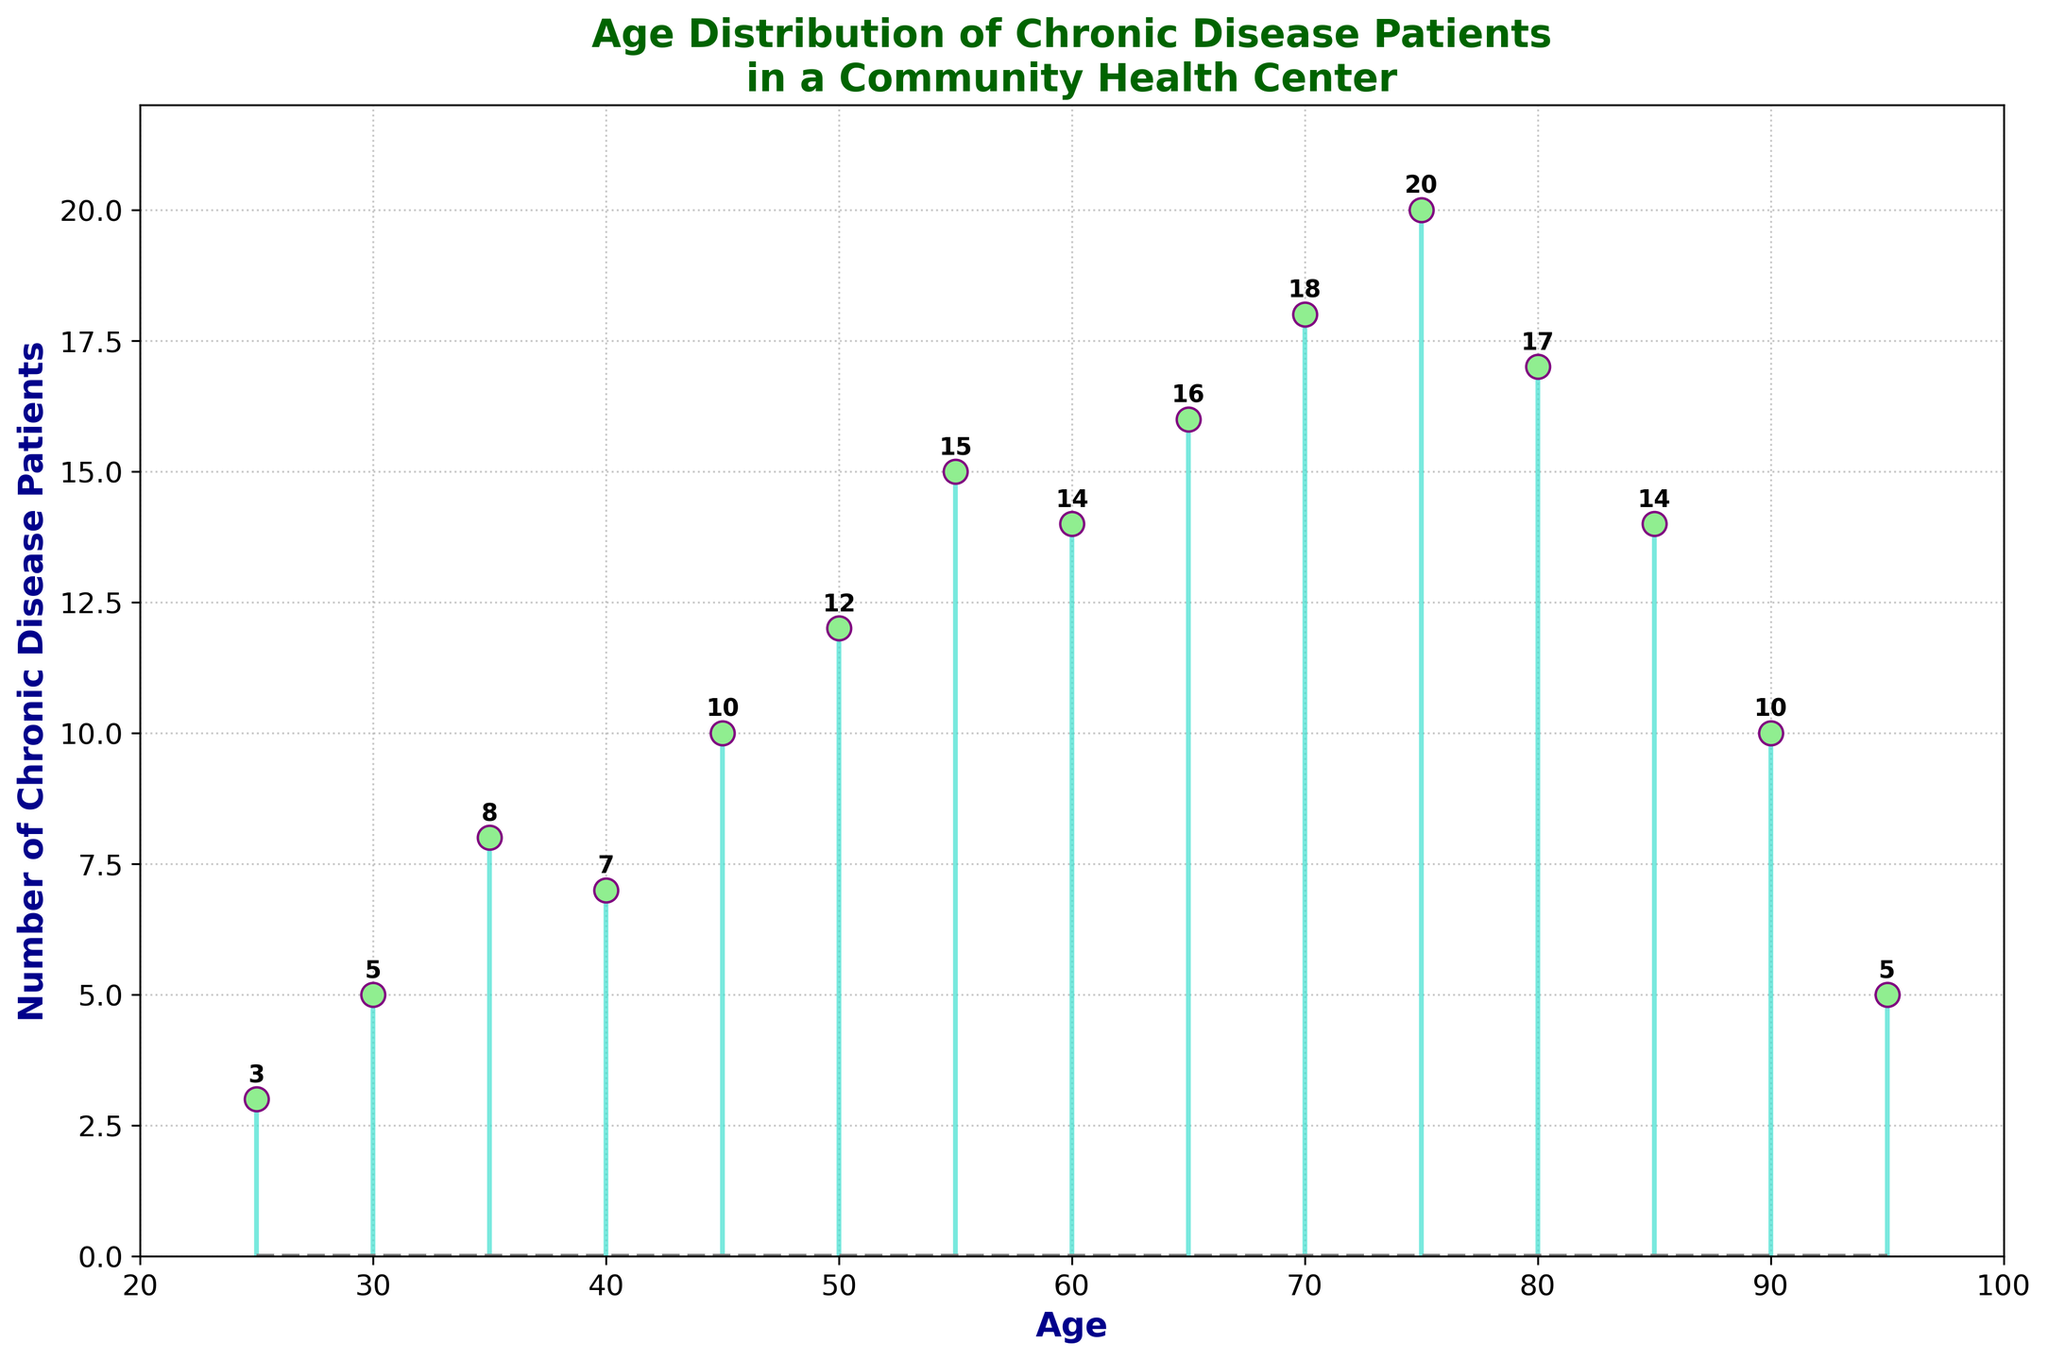What is the highest number of chronic disease patients, and at what age does this occur? To find this information, look for the highest point on the plot's vertical axis and check the corresponding age on the horizontal axis. The highest value on the vertical axis is 20, and this occurs at age 75.
Answer: 20, 75 At which ages are there exactly 14 chronic disease patients? Search for the points on the plot where the value on the vertical axis equals 14 and check the corresponding ages on the horizontal axis. There are two points where the value is 14, which corresponds to ages 60 and 85.
Answer: 60, 85 What are the minimum and maximum age values shown in the figure? The age range can be determined by looking at the first and last points on the horizontal axis in the plot. The minimum age shown is 25, and the maximum age shown is 95.
Answer: 25, 95 What is the total number of chronic disease patients in all age groups combined? To find this sum, add up the values of chronic disease patients for all ages: 3 + 5 + 8 + 7 + 10 + 12 + 15 + 14 + 16 + 18 + 20 + 17 + 14 + 10 + 5 = 174.
Answer: 174 Which age group has fewer chronic disease patients, age 85 or age 90? Compare the number of chronic disease patients at age 85 with those at age 90. At age 85, there are 14 patients, and at age 90, there are 10 patients. Thus, age 90 has fewer patients.
Answer: 90 How does the number of chronic disease patients change between the ages of 50 and 60? Check the number of chronic disease patients at age 50 and compare it to the number at age 60. At age 50, there are 12 patients, and at age 60, there are 14 patients. The number of patients increases by 2.
Answer: Increases by 2 What's the average number of chronic disease patients for all ages shown in the figure? First, find the total number of patients by summing up all numbers: 3 + 5 + 8 + 7 + 10 + 12 + 15 + 14 + 16 + 18 + 20 + 17 + 14 + 10 + 5 = 174. Then, divide this sum by the number of age points (15): 174 / 15 ≈ 11.6.
Answer: 11.6 Which age group has the most significant difference in patients compared to the one immediately before it? Calculate the differences in the number of patients for successive age groups: 5-3=2, 8-5=3, 7-8=-1, 10-7=3, 12-10=2, 15-12=3, 14-15=-1, 16-14=2, 18-16=2, 20-18=2, 17-20=-3, 14-17=-3, 10-14=-4, 5-10=-5. The most significant change is from age 90 to 95 (-5).
Answer: Ages 90 to 95 How many ages have fewer than 10 chronic disease patients? Identify and count the points where the number of patients is below 10: 25 (3), 30 (5), 35 (8), 40 (7), 90 (10), 95 (5). There are 5 ages with values fewer than 10: 25, 30, 35, 40, and 95.
Answer: 5 Which age group sees the first significant increase to double-digit values? Look for the first age where the number of patients reaches double digits (10 or more). The age group where this occurs for the first time is age 45 with 10 patients.
Answer: 45 